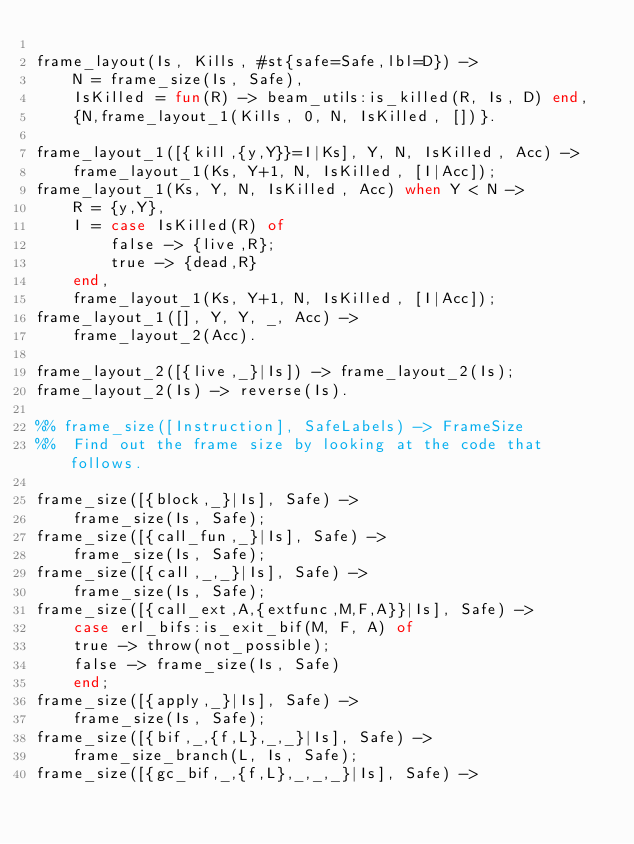<code> <loc_0><loc_0><loc_500><loc_500><_Erlang_>
frame_layout(Is, Kills, #st{safe=Safe,lbl=D}) ->
    N = frame_size(Is, Safe),
    IsKilled = fun(R) -> beam_utils:is_killed(R, Is, D) end,
    {N,frame_layout_1(Kills, 0, N, IsKilled, [])}.

frame_layout_1([{kill,{y,Y}}=I|Ks], Y, N, IsKilled, Acc) ->
    frame_layout_1(Ks, Y+1, N, IsKilled, [I|Acc]);
frame_layout_1(Ks, Y, N, IsKilled, Acc) when Y < N ->
    R = {y,Y},
    I = case IsKilled(R) of
	    false -> {live,R};
	    true -> {dead,R}
	end,
    frame_layout_1(Ks, Y+1, N, IsKilled, [I|Acc]);
frame_layout_1([], Y, Y, _, Acc) ->
    frame_layout_2(Acc).

frame_layout_2([{live,_}|Is]) -> frame_layout_2(Is);
frame_layout_2(Is) -> reverse(Is).

%% frame_size([Instruction], SafeLabels) -> FrameSize
%%  Find out the frame size by looking at the code that follows.

frame_size([{block,_}|Is], Safe) ->
    frame_size(Is, Safe);
frame_size([{call_fun,_}|Is], Safe) ->
    frame_size(Is, Safe);
frame_size([{call,_,_}|Is], Safe) ->
    frame_size(Is, Safe);
frame_size([{call_ext,A,{extfunc,M,F,A}}|Is], Safe) ->
    case erl_bifs:is_exit_bif(M, F, A) of
	true -> throw(not_possible);
	false -> frame_size(Is, Safe)
    end;
frame_size([{apply,_}|Is], Safe) ->
    frame_size(Is, Safe);
frame_size([{bif,_,{f,L},_,_}|Is], Safe) ->
    frame_size_branch(L, Is, Safe);
frame_size([{gc_bif,_,{f,L},_,_,_}|Is], Safe) -></code> 